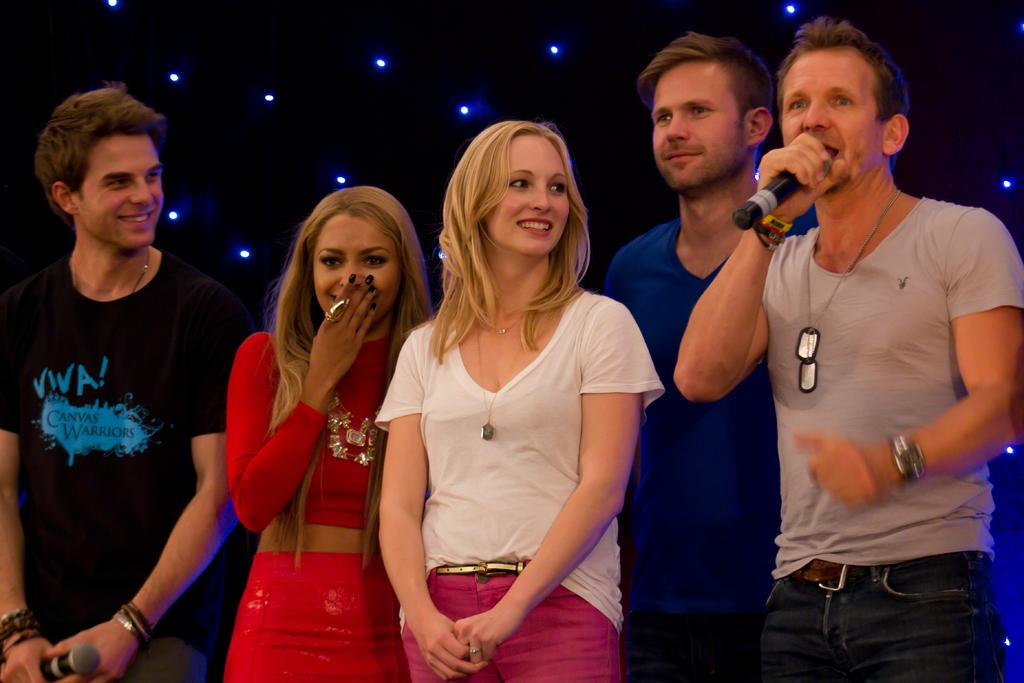What are the people in the image doing? The people in the image are standing and smiling. Can you describe the person holding a microphone? The person holding the microphone is wearing a dress with different colors. What colors can be seen in the background of the image? The background of the image has black and blue colors. What type of loaf is being used as a prop in the image? There is no loaf present in the image. How does the love between the people in the image manifest itself? The love between the people in the image is not explicitly shown, but their smiles may suggest a positive and friendly atmosphere. 